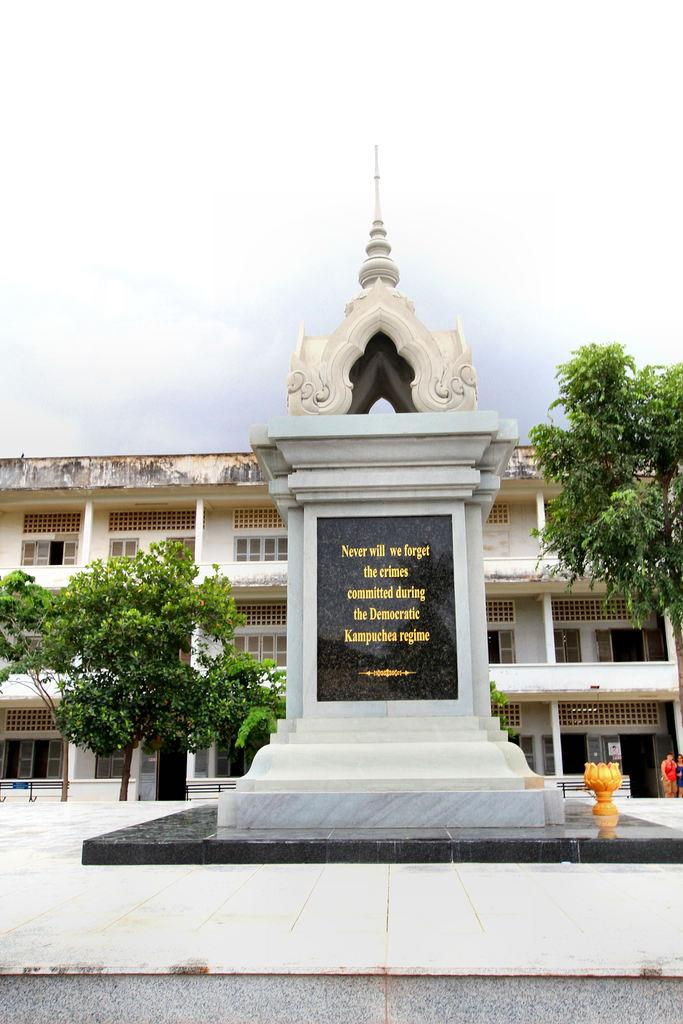Provide a one-sentence caption for the provided image. The plaque ensures that no one will ever forget the crimes committed during this particular regime. 